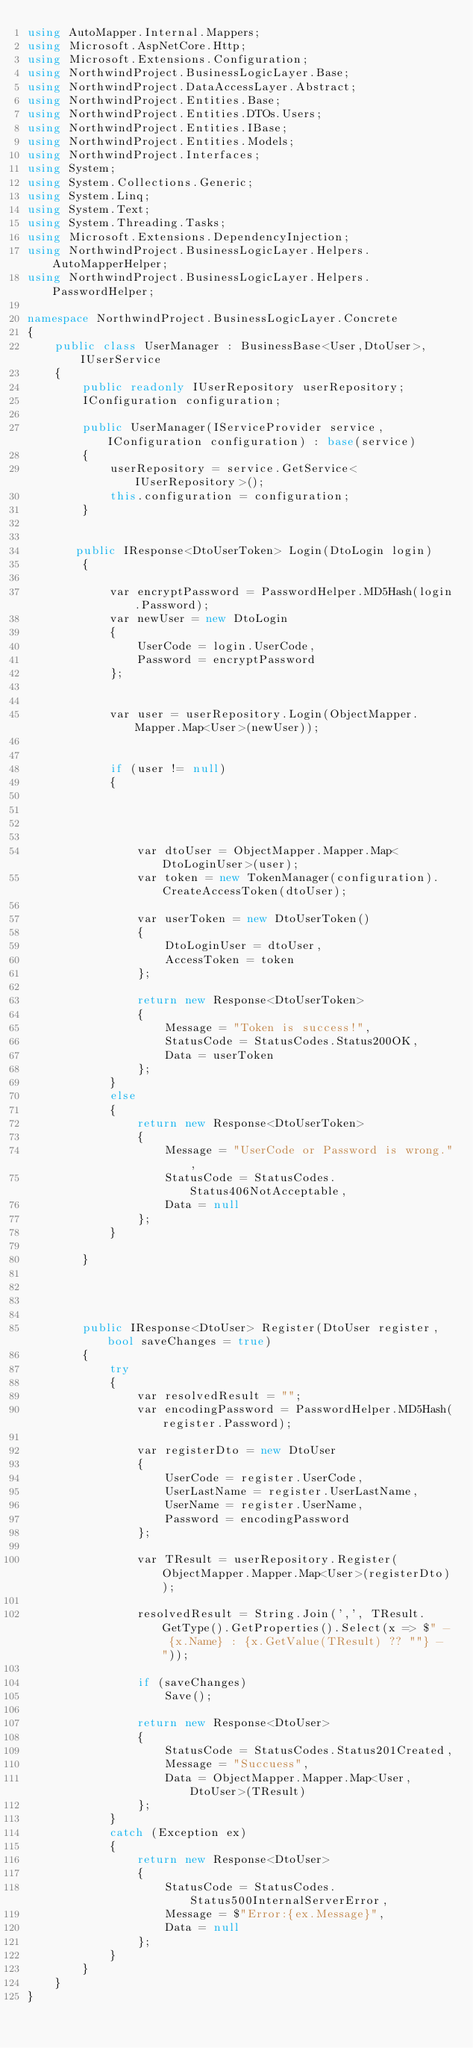Convert code to text. <code><loc_0><loc_0><loc_500><loc_500><_C#_>using AutoMapper.Internal.Mappers;
using Microsoft.AspNetCore.Http;
using Microsoft.Extensions.Configuration;
using NorthwindProject.BusinessLogicLayer.Base;
using NorthwindProject.DataAccessLayer.Abstract;
using NorthwindProject.Entities.Base;
using NorthwindProject.Entities.DTOs.Users;
using NorthwindProject.Entities.IBase;
using NorthwindProject.Entities.Models;
using NorthwindProject.Interfaces;
using System;
using System.Collections.Generic;
using System.Linq;
using System.Text;
using System.Threading.Tasks;
using Microsoft.Extensions.DependencyInjection;
using NorthwindProject.BusinessLogicLayer.Helpers.AutoMapperHelper;
using NorthwindProject.BusinessLogicLayer.Helpers.PasswordHelper;

namespace NorthwindProject.BusinessLogicLayer.Concrete
{
    public class UserManager : BusinessBase<User,DtoUser>,IUserService
    {
        public readonly IUserRepository userRepository;
        IConfiguration configuration;

        public UserManager(IServiceProvider service, IConfiguration configuration) : base(service)
        {
            userRepository = service.GetService<IUserRepository>();
            this.configuration = configuration;
        }

       
       public IResponse<DtoUserToken> Login(DtoLogin login)
        {

            var encryptPassword = PasswordHelper.MD5Hash(login.Password);
            var newUser = new DtoLogin
            {
                UserCode = login.UserCode,
                Password = encryptPassword
            };
            

            var user = userRepository.Login(ObjectMapper.Mapper.Map<User>(newUser));
            

            if (user != null)
            {
                


                
                var dtoUser = ObjectMapper.Mapper.Map<DtoLoginUser>(user);
                var token = new TokenManager(configuration).CreateAccessToken(dtoUser);

                var userToken = new DtoUserToken()
                {
                    DtoLoginUser = dtoUser,
                    AccessToken = token
                };

                return new Response<DtoUserToken>
                {
                    Message = "Token is success!",
                    StatusCode = StatusCodes.Status200OK,
                    Data = userToken
                };
            }
            else
            {
                return new Response<DtoUserToken>
                {
                    Message = "UserCode or Password is wrong.",
                    StatusCode = StatusCodes.Status406NotAcceptable,
                    Data = null
                };
            }

        }


       

        public IResponse<DtoUser> Register(DtoUser register,  bool saveChanges = true)
        {
            try
            {
                var resolvedResult = "";
                var encodingPassword = PasswordHelper.MD5Hash(register.Password);

                var registerDto = new DtoUser
                {
                    UserCode = register.UserCode,
                    UserLastName = register.UserLastName,
                    UserName = register.UserName,
                    Password = encodingPassword
                };
               
                var TResult = userRepository.Register(ObjectMapper.Mapper.Map<User>(registerDto));
                
                resolvedResult = String.Join(',', TResult.GetType().GetProperties().Select(x => $" - {x.Name} : {x.GetValue(TResult) ?? ""} - "));

                if (saveChanges)
                    Save();

                return new Response<DtoUser>
                {
                    StatusCode = StatusCodes.Status201Created,
                    Message = "Succuess",
                    Data = ObjectMapper.Mapper.Map<User, DtoUser>(TResult)
                };
            }
            catch (Exception ex)
            {
                return new Response<DtoUser>
                {
                    StatusCode = StatusCodes.Status500InternalServerError,
                    Message = $"Error:{ex.Message}",
                    Data = null
                };
            }
        }
    }
}
</code> 